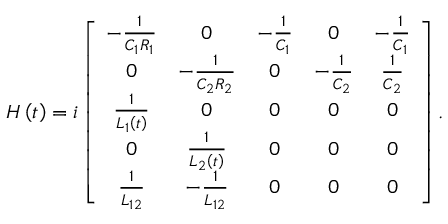<formula> <loc_0><loc_0><loc_500><loc_500>\begin{array} { r } { H \left ( t \right ) = i \left [ \begin{array} { c c c c c } { - \frac { 1 } { C _ { 1 } R _ { 1 } } } & { 0 } & { - \frac { 1 } { C _ { 1 } } } & { 0 } & { - \frac { 1 } { C _ { 1 } } } \\ { 0 } & { - \frac { 1 } { C _ { 2 } R _ { 2 } } } & { 0 } & { - \frac { 1 } { C _ { 2 } } } & { \frac { 1 } { C _ { 2 } } } \\ { \frac { 1 } { L _ { 1 } \left ( t \right ) } } & { 0 } & { 0 } & { 0 } & { 0 } \\ { 0 } & { \frac { 1 } { L _ { 2 } \left ( t \right ) } } & { 0 } & { 0 } & { 0 } \\ { \frac { 1 } { L _ { 1 2 } } } & { - \frac { 1 } { L _ { 1 2 } } } & { 0 } & { 0 } & { 0 } \end{array} \right ] . } \end{array}</formula> 